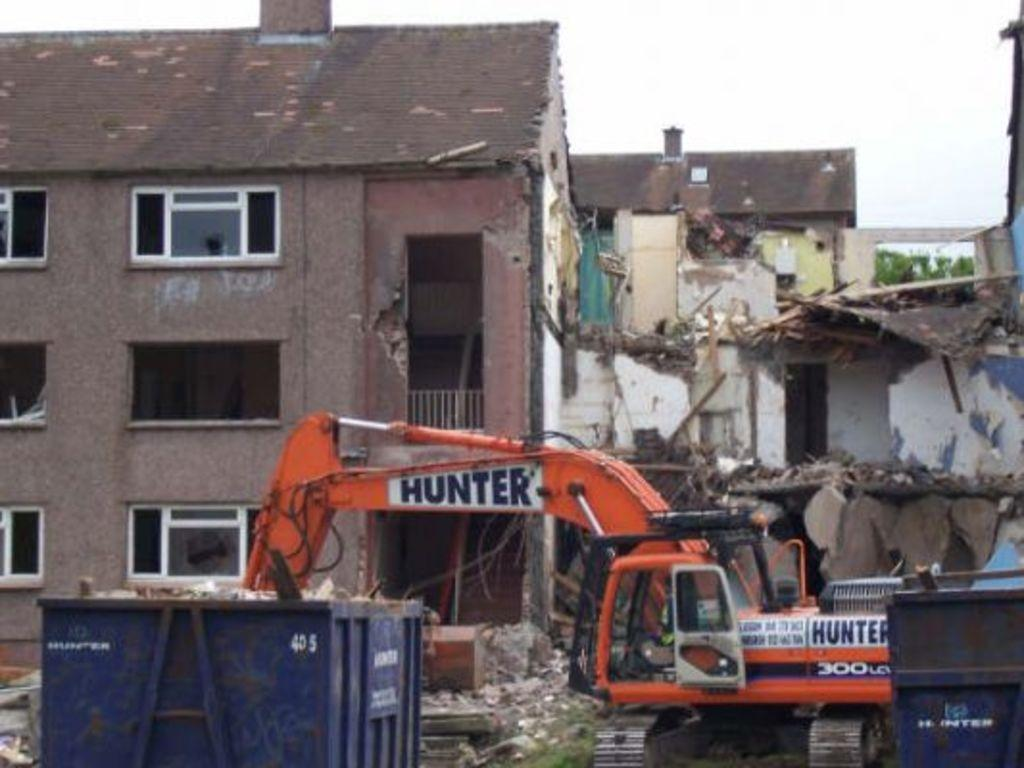What type of machinery is present in the image? There is an excavator in the image. What is located in front of the excavator? There is a steel item in front of the excavator. What can be seen behind the excavator? There are buildings visible behind the excavator. What type of natural elements are visible in the background of the image? There are trees in the background of the image. What part of the natural environment is visible in the image? The sky is visible in the background of the image. What type of education does the excavator have in the image? The excavator is a machine and does not have an education. 